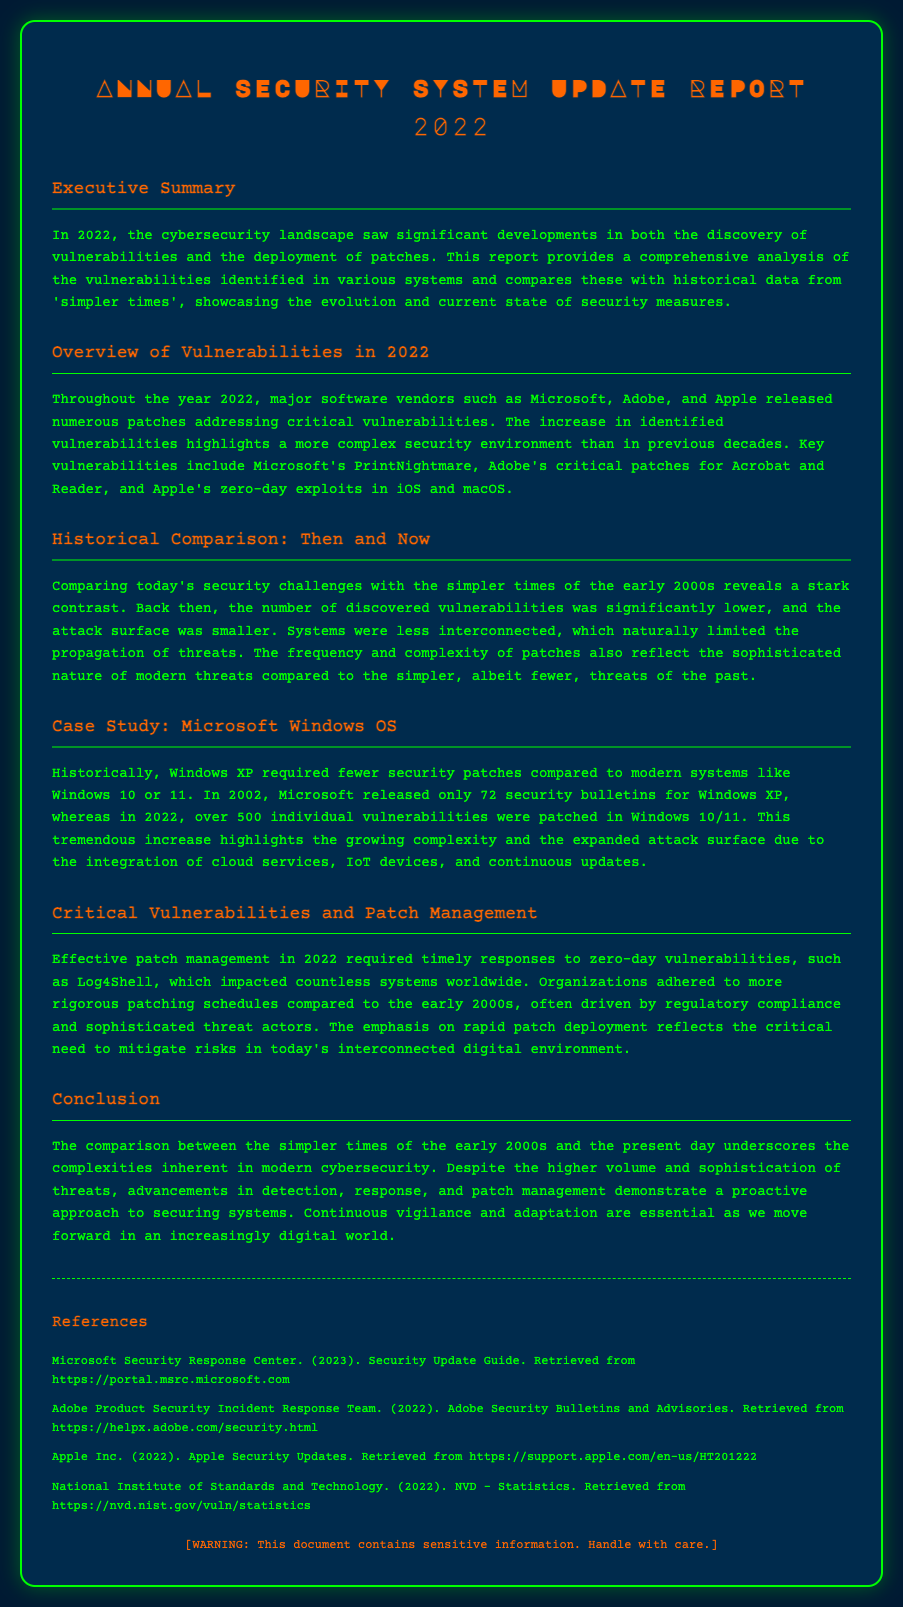What were the two major software vendors mentioned that released patches in 2022? The document lists Microsoft and Adobe as major vendors that released patches addressing vulnerabilities in 2022.
Answer: Microsoft, Adobe How many security bulletins were released for Windows XP in 2002? The document states that in 2002, Microsoft released only 72 security bulletins for Windows XP.
Answer: 72 What key vulnerability associated with Microsoft was highlighted in the report? The report mentions Microsoft's PrintNightmare as a key vulnerability identified in 2022.
Answer: PrintNightmare How many individual vulnerabilities were patched in Windows 10/11 in 2022? According to the document, over 500 individual vulnerabilities were patched in Windows 10/11 in 2022.
Answer: Over 500 What critical vulnerability impacted countless systems worldwide in 2022? The document refers to Log4Shell as a critical vulnerability that had a significant impact in 2022.
Answer: Log4Shell What is one reason mentioned for organizations adhering to more rigorous patching schedules? The document mentions regulatory compliance as a reason for organizations to stick to stricter patching schedules.
Answer: Regulatory compliance What color is the background of the report's envelope? The document describes the background color of the envelope as #002b4d.
Answer: #002b4d Which historical period is compared to 2022 in terms of cybersecurity challenges? The document refers to the early 2000s as the historical period compared to modern challenges in 2022.
Answer: Early 2000s What phrase is used to describe the need for continuous action in cybersecurity as described in the conclusion? The document states that continuous vigilance and adaptation are essential in the conclusion.
Answer: Continuous vigilance and adaptation 